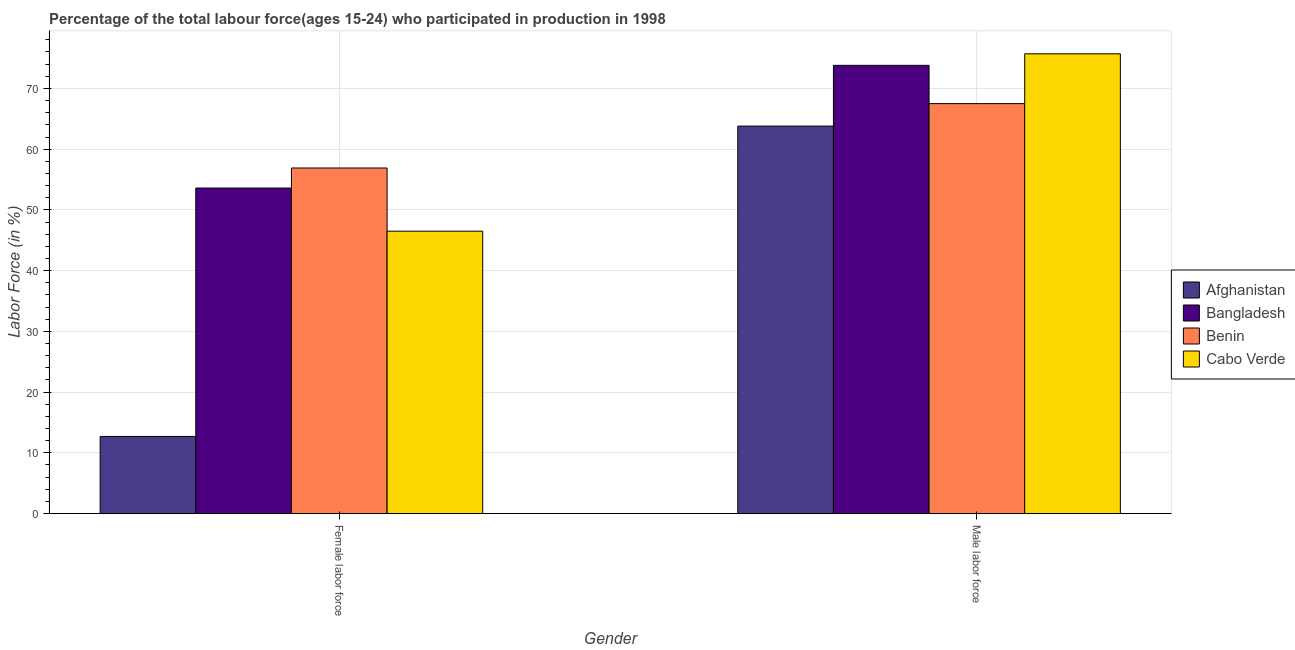Are the number of bars on each tick of the X-axis equal?
Keep it short and to the point. Yes. What is the label of the 1st group of bars from the left?
Provide a short and direct response. Female labor force. What is the percentage of female labor force in Bangladesh?
Offer a very short reply. 53.6. Across all countries, what is the maximum percentage of female labor force?
Provide a short and direct response. 56.9. Across all countries, what is the minimum percentage of female labor force?
Your answer should be compact. 12.7. In which country was the percentage of female labor force maximum?
Ensure brevity in your answer.  Benin. In which country was the percentage of male labour force minimum?
Offer a terse response. Afghanistan. What is the total percentage of female labor force in the graph?
Your response must be concise. 169.7. What is the difference between the percentage of male labour force in Bangladesh and that in Cabo Verde?
Give a very brief answer. -1.9. What is the average percentage of female labor force per country?
Provide a succinct answer. 42.42. What is the difference between the percentage of female labor force and percentage of male labour force in Cabo Verde?
Provide a succinct answer. -29.2. In how many countries, is the percentage of female labor force greater than 64 %?
Provide a short and direct response. 0. What is the ratio of the percentage of female labor force in Afghanistan to that in Cabo Verde?
Make the answer very short. 0.27. In how many countries, is the percentage of male labour force greater than the average percentage of male labour force taken over all countries?
Your answer should be compact. 2. What does the 2nd bar from the left in Male labor force represents?
Give a very brief answer. Bangladesh. What does the 2nd bar from the right in Female labor force represents?
Your answer should be very brief. Benin. Are all the bars in the graph horizontal?
Give a very brief answer. No. How many countries are there in the graph?
Provide a short and direct response. 4. Does the graph contain any zero values?
Ensure brevity in your answer.  No. Does the graph contain grids?
Give a very brief answer. Yes. How are the legend labels stacked?
Keep it short and to the point. Vertical. What is the title of the graph?
Ensure brevity in your answer.  Percentage of the total labour force(ages 15-24) who participated in production in 1998. Does "Indonesia" appear as one of the legend labels in the graph?
Provide a succinct answer. No. What is the label or title of the X-axis?
Provide a succinct answer. Gender. What is the label or title of the Y-axis?
Ensure brevity in your answer.  Labor Force (in %). What is the Labor Force (in %) in Afghanistan in Female labor force?
Give a very brief answer. 12.7. What is the Labor Force (in %) of Bangladesh in Female labor force?
Keep it short and to the point. 53.6. What is the Labor Force (in %) of Benin in Female labor force?
Make the answer very short. 56.9. What is the Labor Force (in %) of Cabo Verde in Female labor force?
Ensure brevity in your answer.  46.5. What is the Labor Force (in %) of Afghanistan in Male labor force?
Your response must be concise. 63.8. What is the Labor Force (in %) of Bangladesh in Male labor force?
Provide a short and direct response. 73.8. What is the Labor Force (in %) in Benin in Male labor force?
Provide a succinct answer. 67.5. What is the Labor Force (in %) of Cabo Verde in Male labor force?
Provide a succinct answer. 75.7. Across all Gender, what is the maximum Labor Force (in %) of Afghanistan?
Give a very brief answer. 63.8. Across all Gender, what is the maximum Labor Force (in %) of Bangladesh?
Your answer should be compact. 73.8. Across all Gender, what is the maximum Labor Force (in %) of Benin?
Give a very brief answer. 67.5. Across all Gender, what is the maximum Labor Force (in %) of Cabo Verde?
Offer a very short reply. 75.7. Across all Gender, what is the minimum Labor Force (in %) in Afghanistan?
Give a very brief answer. 12.7. Across all Gender, what is the minimum Labor Force (in %) in Bangladesh?
Provide a short and direct response. 53.6. Across all Gender, what is the minimum Labor Force (in %) in Benin?
Provide a succinct answer. 56.9. Across all Gender, what is the minimum Labor Force (in %) of Cabo Verde?
Your answer should be very brief. 46.5. What is the total Labor Force (in %) of Afghanistan in the graph?
Offer a very short reply. 76.5. What is the total Labor Force (in %) of Bangladesh in the graph?
Your answer should be compact. 127.4. What is the total Labor Force (in %) in Benin in the graph?
Your answer should be compact. 124.4. What is the total Labor Force (in %) in Cabo Verde in the graph?
Your answer should be compact. 122.2. What is the difference between the Labor Force (in %) in Afghanistan in Female labor force and that in Male labor force?
Make the answer very short. -51.1. What is the difference between the Labor Force (in %) of Bangladesh in Female labor force and that in Male labor force?
Give a very brief answer. -20.2. What is the difference between the Labor Force (in %) of Cabo Verde in Female labor force and that in Male labor force?
Make the answer very short. -29.2. What is the difference between the Labor Force (in %) of Afghanistan in Female labor force and the Labor Force (in %) of Bangladesh in Male labor force?
Give a very brief answer. -61.1. What is the difference between the Labor Force (in %) of Afghanistan in Female labor force and the Labor Force (in %) of Benin in Male labor force?
Ensure brevity in your answer.  -54.8. What is the difference between the Labor Force (in %) of Afghanistan in Female labor force and the Labor Force (in %) of Cabo Verde in Male labor force?
Offer a terse response. -63. What is the difference between the Labor Force (in %) in Bangladesh in Female labor force and the Labor Force (in %) in Cabo Verde in Male labor force?
Make the answer very short. -22.1. What is the difference between the Labor Force (in %) in Benin in Female labor force and the Labor Force (in %) in Cabo Verde in Male labor force?
Provide a succinct answer. -18.8. What is the average Labor Force (in %) of Afghanistan per Gender?
Provide a short and direct response. 38.25. What is the average Labor Force (in %) in Bangladesh per Gender?
Your answer should be very brief. 63.7. What is the average Labor Force (in %) of Benin per Gender?
Offer a terse response. 62.2. What is the average Labor Force (in %) in Cabo Verde per Gender?
Your answer should be compact. 61.1. What is the difference between the Labor Force (in %) of Afghanistan and Labor Force (in %) of Bangladesh in Female labor force?
Keep it short and to the point. -40.9. What is the difference between the Labor Force (in %) in Afghanistan and Labor Force (in %) in Benin in Female labor force?
Offer a very short reply. -44.2. What is the difference between the Labor Force (in %) in Afghanistan and Labor Force (in %) in Cabo Verde in Female labor force?
Your answer should be very brief. -33.8. What is the difference between the Labor Force (in %) of Afghanistan and Labor Force (in %) of Bangladesh in Male labor force?
Your answer should be very brief. -10. What is the difference between the Labor Force (in %) of Afghanistan and Labor Force (in %) of Benin in Male labor force?
Your answer should be compact. -3.7. What is the difference between the Labor Force (in %) of Bangladesh and Labor Force (in %) of Benin in Male labor force?
Provide a short and direct response. 6.3. What is the difference between the Labor Force (in %) in Benin and Labor Force (in %) in Cabo Verde in Male labor force?
Your answer should be compact. -8.2. What is the ratio of the Labor Force (in %) in Afghanistan in Female labor force to that in Male labor force?
Your answer should be very brief. 0.2. What is the ratio of the Labor Force (in %) of Bangladesh in Female labor force to that in Male labor force?
Your answer should be very brief. 0.73. What is the ratio of the Labor Force (in %) of Benin in Female labor force to that in Male labor force?
Provide a short and direct response. 0.84. What is the ratio of the Labor Force (in %) of Cabo Verde in Female labor force to that in Male labor force?
Your answer should be very brief. 0.61. What is the difference between the highest and the second highest Labor Force (in %) in Afghanistan?
Provide a short and direct response. 51.1. What is the difference between the highest and the second highest Labor Force (in %) in Bangladesh?
Your answer should be very brief. 20.2. What is the difference between the highest and the second highest Labor Force (in %) in Cabo Verde?
Offer a very short reply. 29.2. What is the difference between the highest and the lowest Labor Force (in %) in Afghanistan?
Offer a terse response. 51.1. What is the difference between the highest and the lowest Labor Force (in %) of Bangladesh?
Your response must be concise. 20.2. What is the difference between the highest and the lowest Labor Force (in %) in Benin?
Keep it short and to the point. 10.6. What is the difference between the highest and the lowest Labor Force (in %) in Cabo Verde?
Your response must be concise. 29.2. 